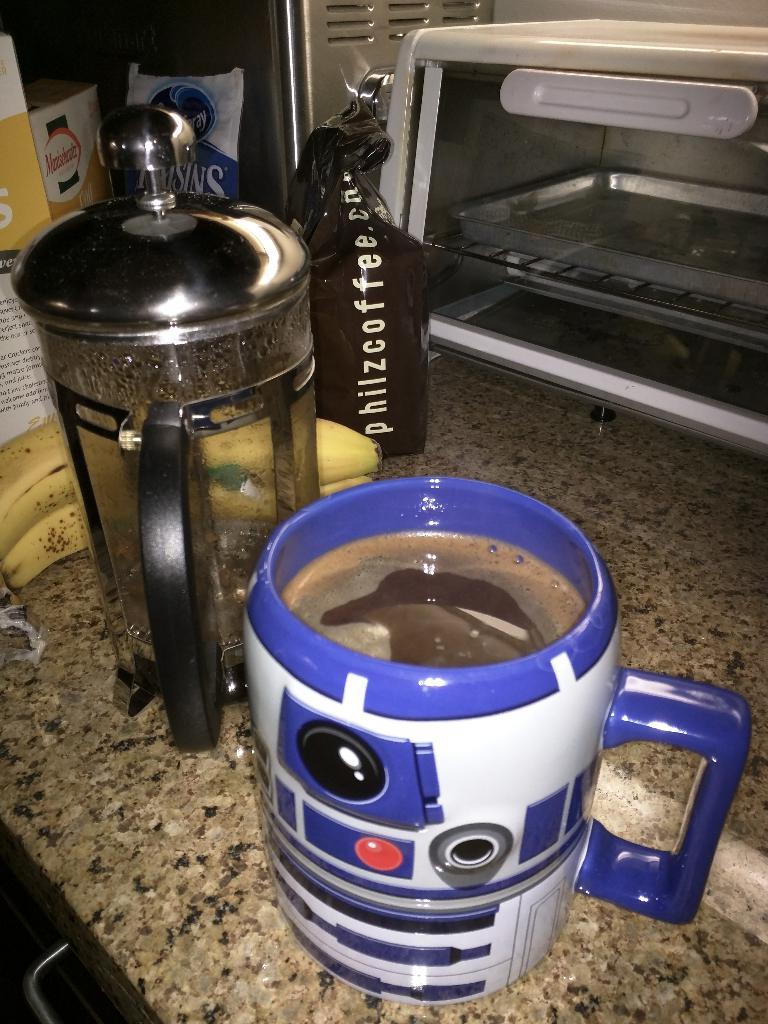What does the black bag say?
Provide a succinct answer. Philzcoffee.com. 